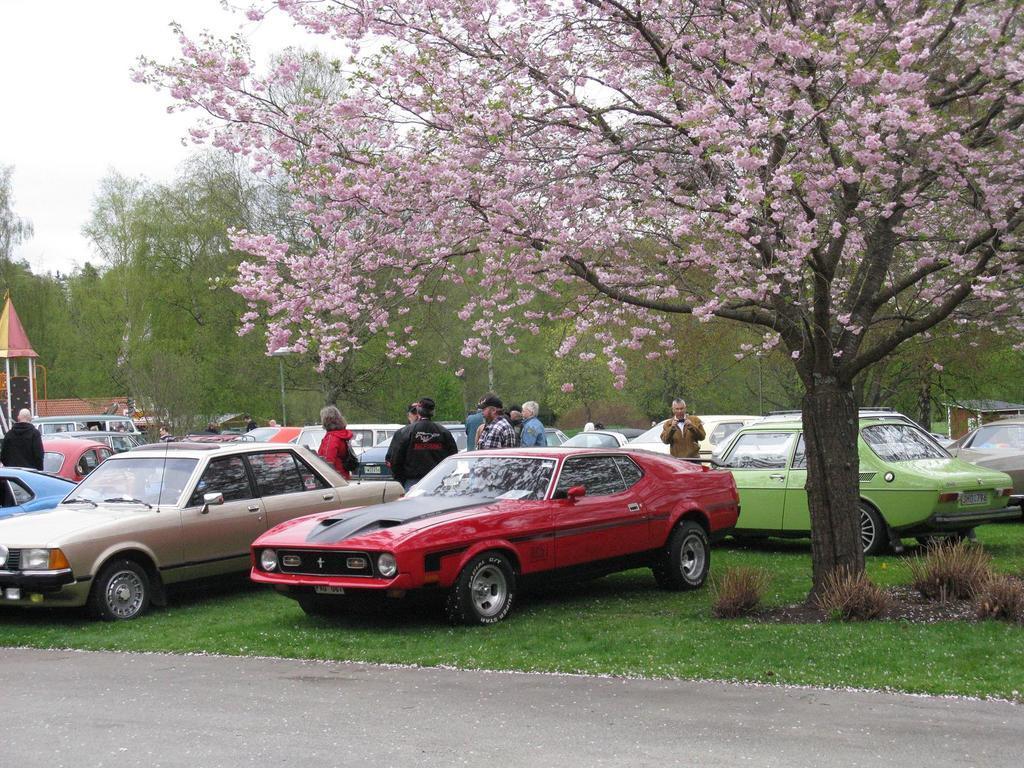How would you summarize this image in a sentence or two? In this picture I can see trees and few cars parked and few people standing and I can see grass on the ground and few plants and I can see a cloudy sky. 